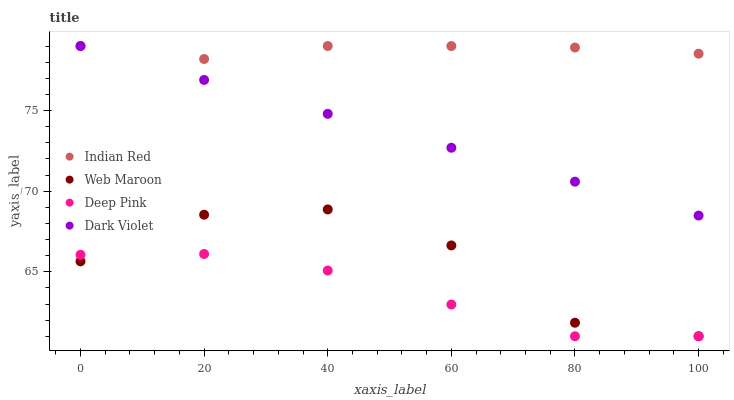Does Deep Pink have the minimum area under the curve?
Answer yes or no. Yes. Does Indian Red have the maximum area under the curve?
Answer yes or no. Yes. Does Web Maroon have the minimum area under the curve?
Answer yes or no. No. Does Web Maroon have the maximum area under the curve?
Answer yes or no. No. Is Dark Violet the smoothest?
Answer yes or no. Yes. Is Web Maroon the roughest?
Answer yes or no. Yes. Is Web Maroon the smoothest?
Answer yes or no. No. Is Dark Violet the roughest?
Answer yes or no. No. Does Deep Pink have the lowest value?
Answer yes or no. Yes. Does Dark Violet have the lowest value?
Answer yes or no. No. Does Indian Red have the highest value?
Answer yes or no. Yes. Does Web Maroon have the highest value?
Answer yes or no. No. Is Deep Pink less than Indian Red?
Answer yes or no. Yes. Is Dark Violet greater than Deep Pink?
Answer yes or no. Yes. Does Dark Violet intersect Indian Red?
Answer yes or no. Yes. Is Dark Violet less than Indian Red?
Answer yes or no. No. Is Dark Violet greater than Indian Red?
Answer yes or no. No. Does Deep Pink intersect Indian Red?
Answer yes or no. No. 